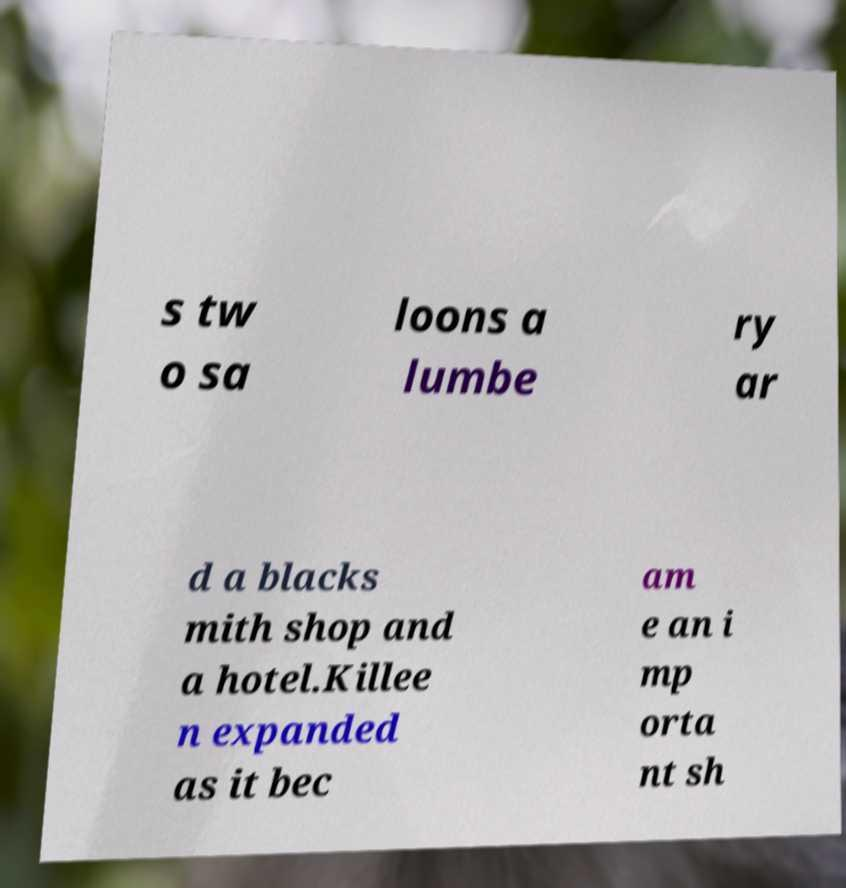For documentation purposes, I need the text within this image transcribed. Could you provide that? s tw o sa loons a lumbe ry ar d a blacks mith shop and a hotel.Killee n expanded as it bec am e an i mp orta nt sh 